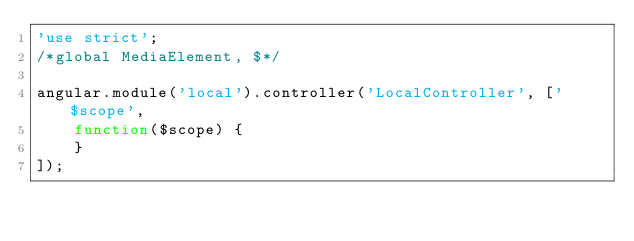Convert code to text. <code><loc_0><loc_0><loc_500><loc_500><_JavaScript_>'use strict';
/*global MediaElement, $*/

angular.module('local').controller('LocalController', ['$scope',
	function($scope) {
	}
]);</code> 